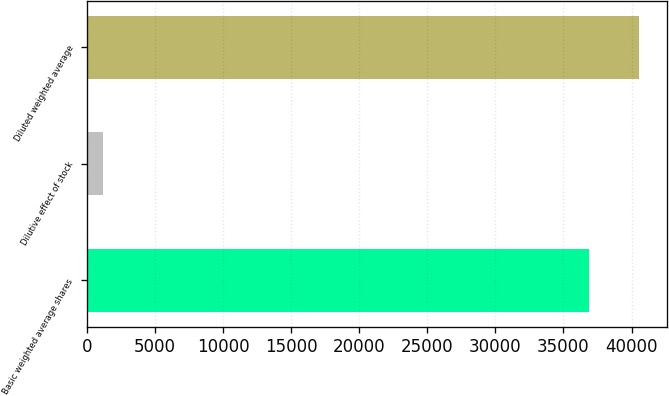<chart> <loc_0><loc_0><loc_500><loc_500><bar_chart><fcel>Basic weighted average shares<fcel>Dilutive effect of stock<fcel>Diluted weighted average<nl><fcel>36864<fcel>1174<fcel>40550.4<nl></chart> 